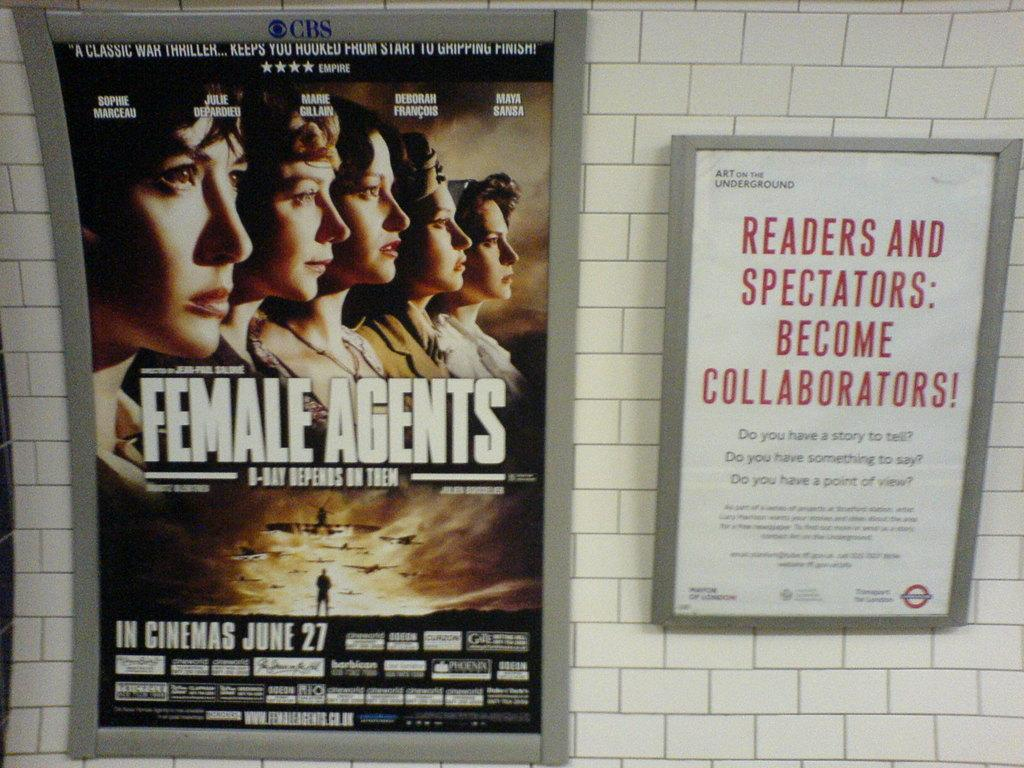<image>
Relay a brief, clear account of the picture shown. posters on a white tiled wall with one saying Female Agents 